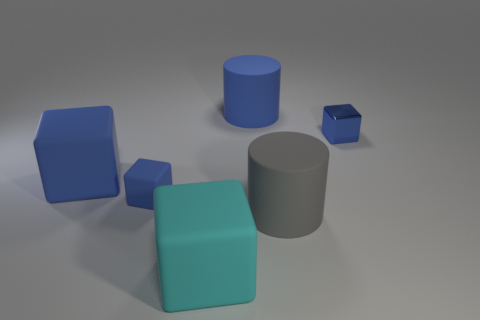Subtract all blue blocks. How many blocks are left? 1 Subtract 0 blue spheres. How many objects are left? 6 Subtract all cubes. How many objects are left? 2 Subtract 1 cubes. How many cubes are left? 3 Subtract all yellow blocks. Subtract all brown spheres. How many blocks are left? 4 Subtract all cyan cylinders. How many red blocks are left? 0 Subtract all tiny shiny blocks. Subtract all large cyan blocks. How many objects are left? 4 Add 1 blue rubber cylinders. How many blue rubber cylinders are left? 2 Add 3 blue cylinders. How many blue cylinders exist? 4 Add 4 small metallic blocks. How many objects exist? 10 